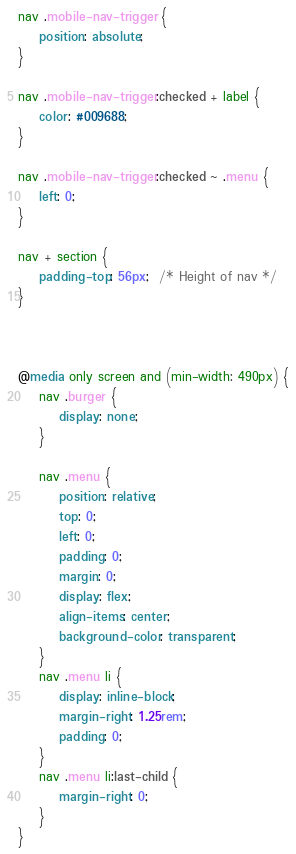Convert code to text. <code><loc_0><loc_0><loc_500><loc_500><_CSS_>nav .mobile-nav-trigger {
    position: absolute;
}

nav .mobile-nav-trigger:checked + label {
    color: #009688;
}

nav .mobile-nav-trigger:checked ~ .menu {
    left: 0;
}

nav + section {
    padding-top: 56px;  /* Height of nav */
}



@media only screen and (min-width: 490px) {
    nav .burger {
        display: none;
    }

    nav .menu {
        position: relative;
        top: 0;
        left: 0;
        padding: 0;
        margin: 0;
        display: flex;
        align-items: center;
        background-color: transparent;
    }
    nav .menu li {
        display: inline-block;
        margin-right: 1.25rem;
        padding: 0;
    }
    nav .menu li:last-child {
        margin-right: 0;
    }
}</code> 